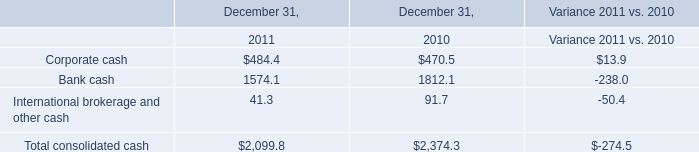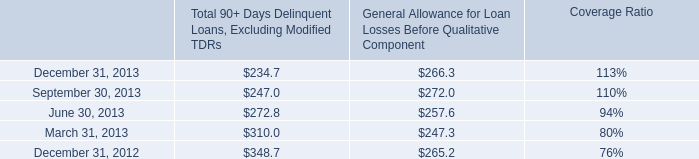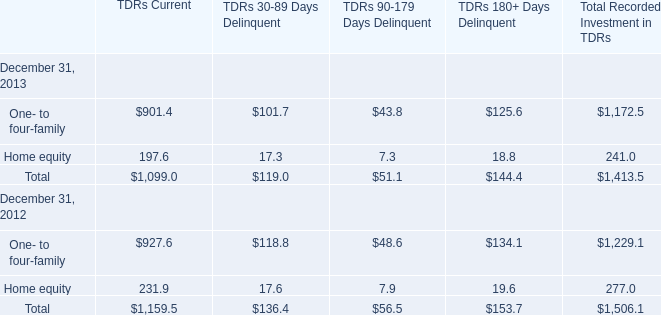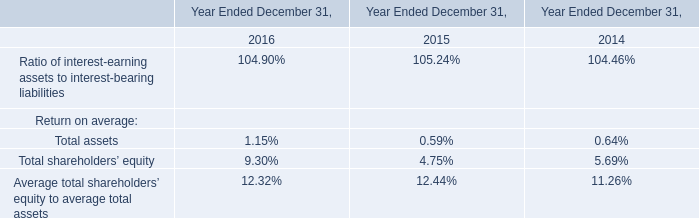Which year is Total 90+ Days Delinquent Loans, Excluding Modified TDRs the least? 
Answer: 2013. 